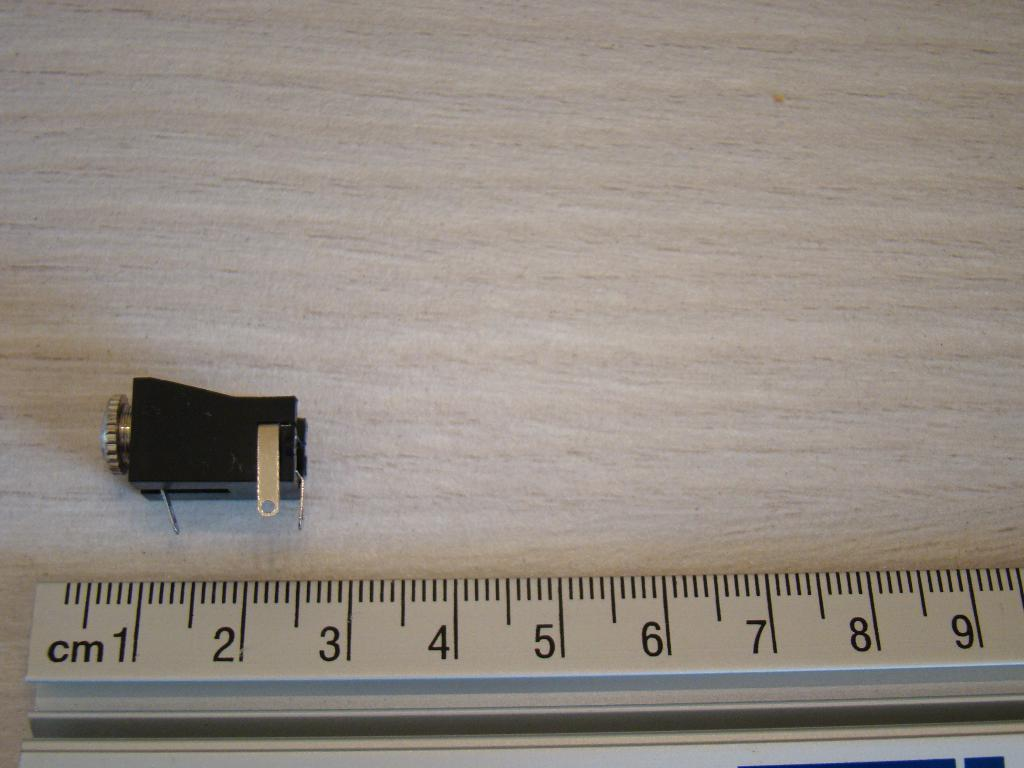Provide a one-sentence caption for the provided image. A black gadget is laid above a ruler marked with centimeters that shows it is approximately 2cm long. 